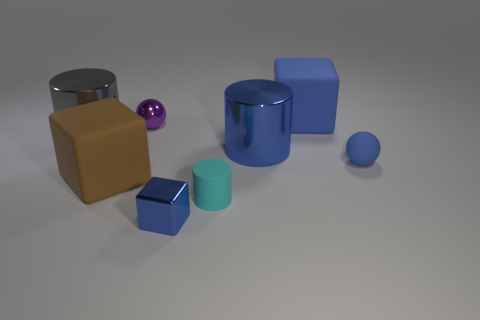What material is the object that is behind the large gray metallic object and in front of the big blue rubber block?
Your answer should be compact. Metal. What is the color of the large thing that is both to the right of the cyan cylinder and in front of the big blue block?
Give a very brief answer. Blue. Is there any other thing that is the same color as the tiny rubber sphere?
Keep it short and to the point. Yes. What is the shape of the large metal object to the left of the tiny sphere behind the big shiny object left of the tiny rubber cylinder?
Offer a terse response. Cylinder. What color is the other small thing that is the same shape as the brown object?
Provide a short and direct response. Blue. What is the color of the metal object left of the tiny ball that is on the left side of the large blue matte block?
Provide a succinct answer. Gray. What is the size of the brown object that is the same shape as the big blue rubber object?
Keep it short and to the point. Large. How many small cylinders have the same material as the brown cube?
Offer a terse response. 1. There is a block that is behind the big gray shiny cylinder; what number of blue rubber things are in front of it?
Your response must be concise. 1. There is a tiny purple shiny sphere; are there any big blue things behind it?
Provide a short and direct response. Yes. 